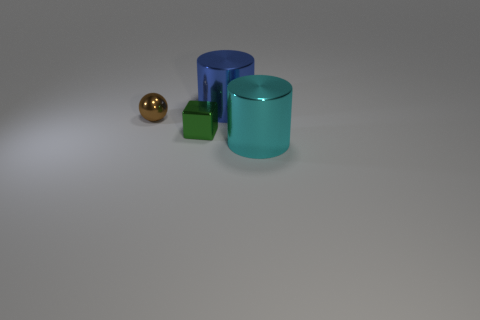The green block that is the same material as the large cyan cylinder is what size?
Offer a very short reply. Small. There is a blue shiny thing that is the same shape as the large cyan metal thing; what size is it?
Ensure brevity in your answer.  Large. There is a cylinder left of the cyan cylinder; how big is it?
Make the answer very short. Large. What color is the other big object that is the same shape as the big blue metallic thing?
Provide a short and direct response. Cyan. Are there any other things that have the same shape as the tiny brown thing?
Provide a short and direct response. No. There is a cylinder in front of the tiny shiny thing in front of the small metal ball; are there any blue things that are on the right side of it?
Ensure brevity in your answer.  No. What number of small blue balls are made of the same material as the tiny green thing?
Your answer should be compact. 0. Is the size of the object to the right of the blue metallic cylinder the same as the metal cylinder on the left side of the big cyan cylinder?
Ensure brevity in your answer.  Yes. There is a large thing that is behind the large cylinder in front of the metal cylinder behind the brown thing; what color is it?
Give a very brief answer. Blue. Is there a cyan object of the same shape as the green object?
Provide a succinct answer. No. 